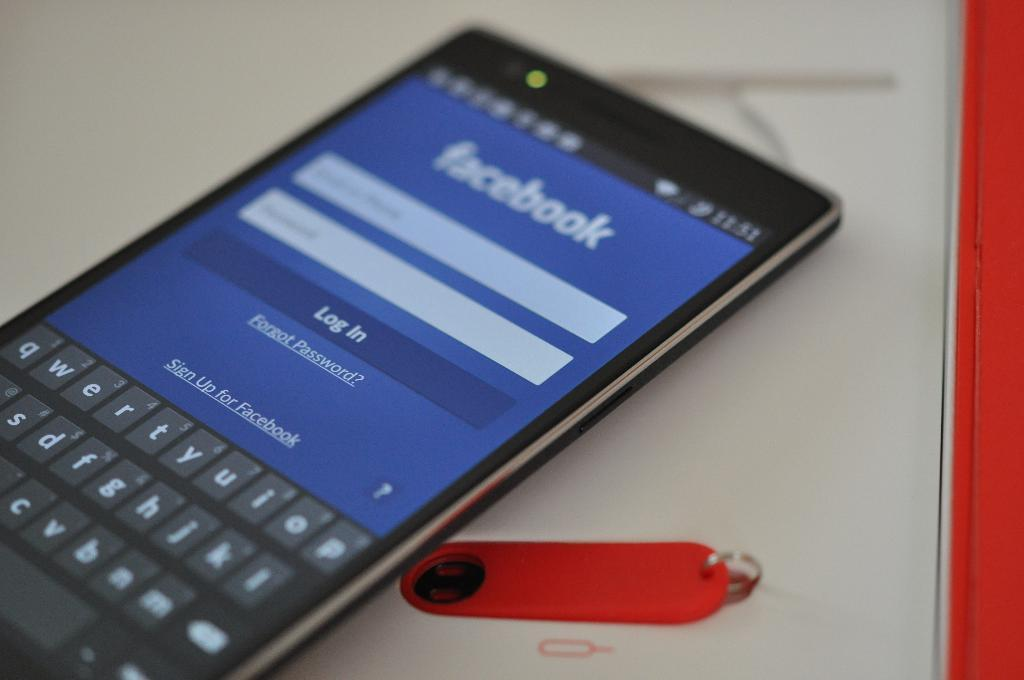<image>
Summarize the visual content of the image. The owner of this phone is just about to log in to their facebook page. 